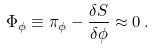Convert formula to latex. <formula><loc_0><loc_0><loc_500><loc_500>\Phi _ { \phi } \equiv \pi _ { \phi } - \frac { \delta S } { \delta \phi } \approx 0 \, .</formula> 